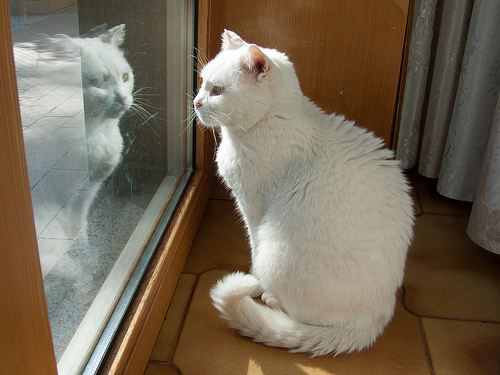<image>
Is the cat on the patio? No. The cat is not positioned on the patio. They may be near each other, but the cat is not supported by or resting on top of the patio. Is the cat in front of the reflection? Yes. The cat is positioned in front of the reflection, appearing closer to the camera viewpoint. 